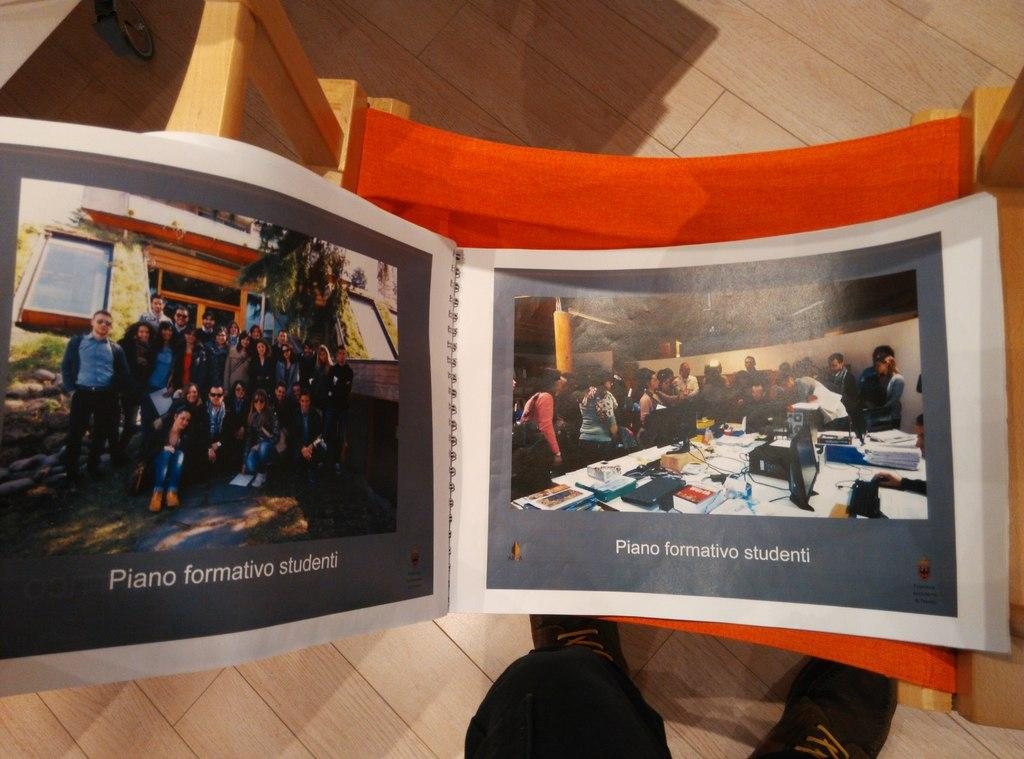Provide a one-sentence caption for the provided image. The picture album contained images for the "Piano formativo studenti" club. 